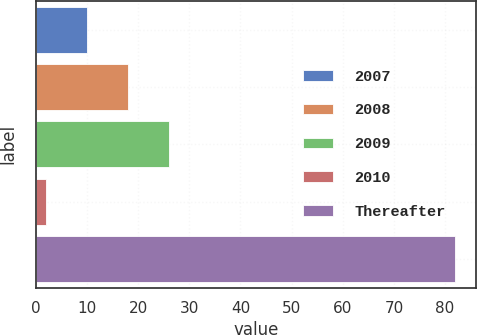Convert chart to OTSL. <chart><loc_0><loc_0><loc_500><loc_500><bar_chart><fcel>2007<fcel>2008<fcel>2009<fcel>2010<fcel>Thereafter<nl><fcel>10<fcel>18<fcel>26<fcel>2<fcel>82<nl></chart> 